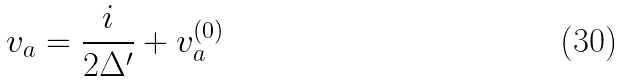<formula> <loc_0><loc_0><loc_500><loc_500>v _ { a } = \frac { i } { 2 \Delta ^ { \prime } } + v ^ { ( 0 ) } _ { a }</formula> 